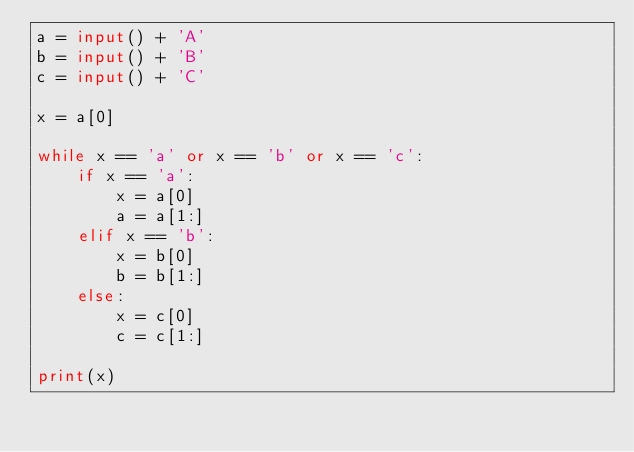<code> <loc_0><loc_0><loc_500><loc_500><_Python_>a = input() + 'A'
b = input() + 'B'
c = input() + 'C'

x = a[0]

while x == 'a' or x == 'b' or x == 'c':
    if x == 'a':
        x = a[0]
        a = a[1:]
    elif x == 'b':
        x = b[0]
        b = b[1:]
    else:
        x = c[0]
        c = c[1:]

print(x)
</code> 